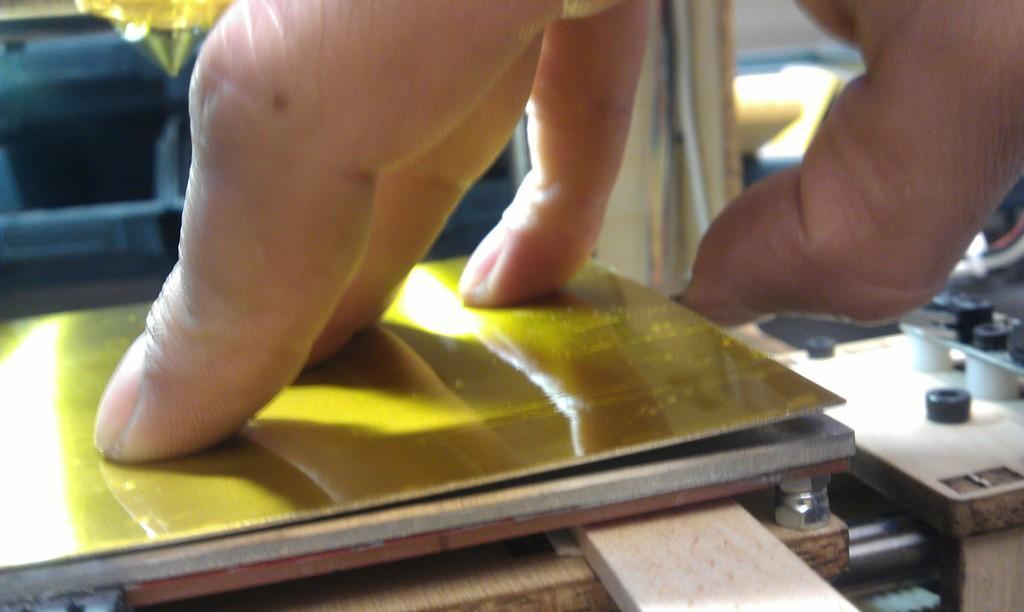Can you describe this image briefly? In this image we can see fingers of a person. Also there is a yellow color board. And there are bolts. 